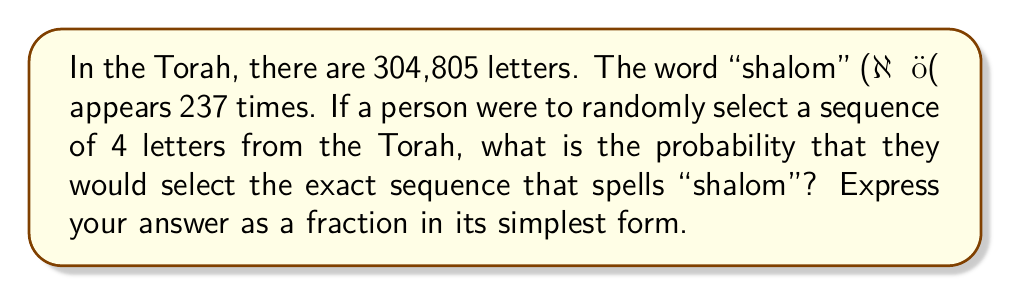Help me with this question. To solve this problem, we need to follow these steps:

1. Calculate the total number of possible 4-letter sequences in the Torah.
2. Calculate the number of times "shalom" appears.
3. Divide the number of "shalom" appearances by the total number of possible sequences.

Step 1: Calculating the total number of possible 4-letter sequences
The total number of 4-letter sequences is equal to the number of ways we can choose the starting position of our sequence. Since there are 304,805 letters, and we need 4 consecutive letters, the number of possible starting positions is:

$$ 304,805 - 3 = 304,802 $$

Step 2: Number of "shalom" appearances
We are given that "shalom" appears 237 times in the Torah.

Step 3: Calculating the probability
The probability is the number of favorable outcomes divided by the total number of possible outcomes:

$$ P(\text{selecting "shalom"}) = \frac{\text{number of "shalom" appearances}}{\text{total number of possible 4-letter sequences}} $$

$$ P(\text{selecting "shalom"}) = \frac{237}{304,802} $$

This fraction can be simplified by dividing both the numerator and denominator by their greatest common divisor (GCD). The GCD of 237 and 304,802 is 1, so this fraction is already in its simplest form.
Answer: $\frac{237}{304,802}$ 